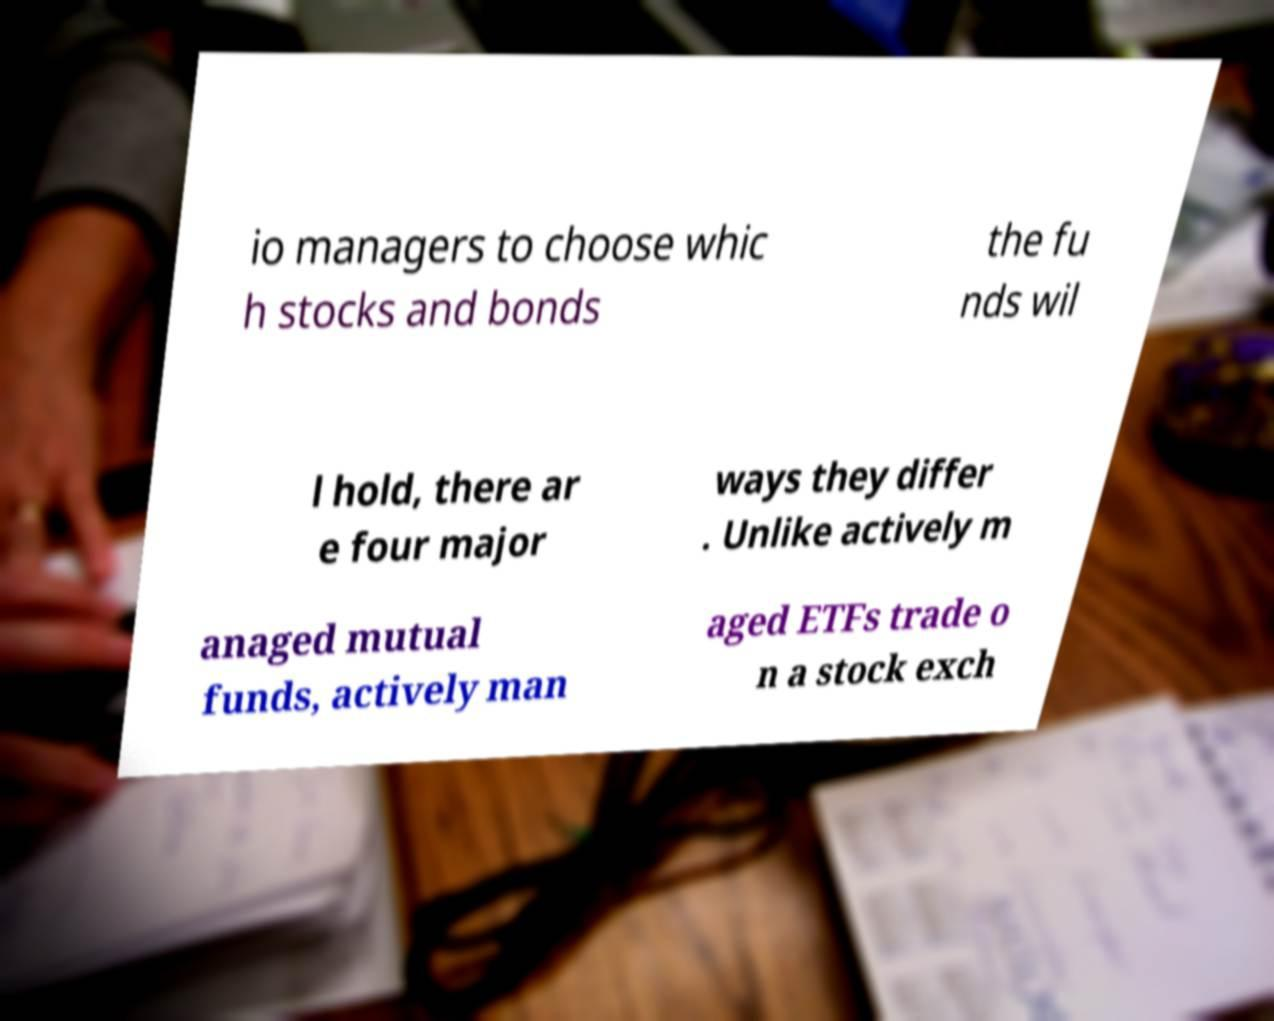Can you accurately transcribe the text from the provided image for me? io managers to choose whic h stocks and bonds the fu nds wil l hold, there ar e four major ways they differ . Unlike actively m anaged mutual funds, actively man aged ETFs trade o n a stock exch 